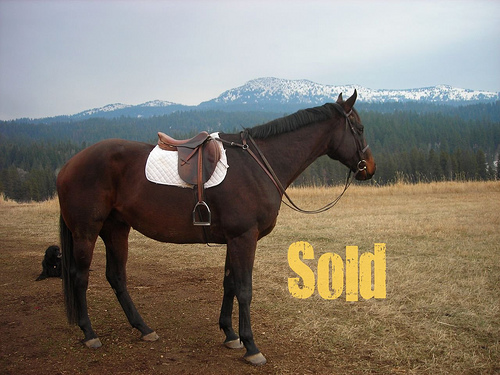<image>
Is there a writing next to the horse? Yes. The writing is positioned adjacent to the horse, located nearby in the same general area. 